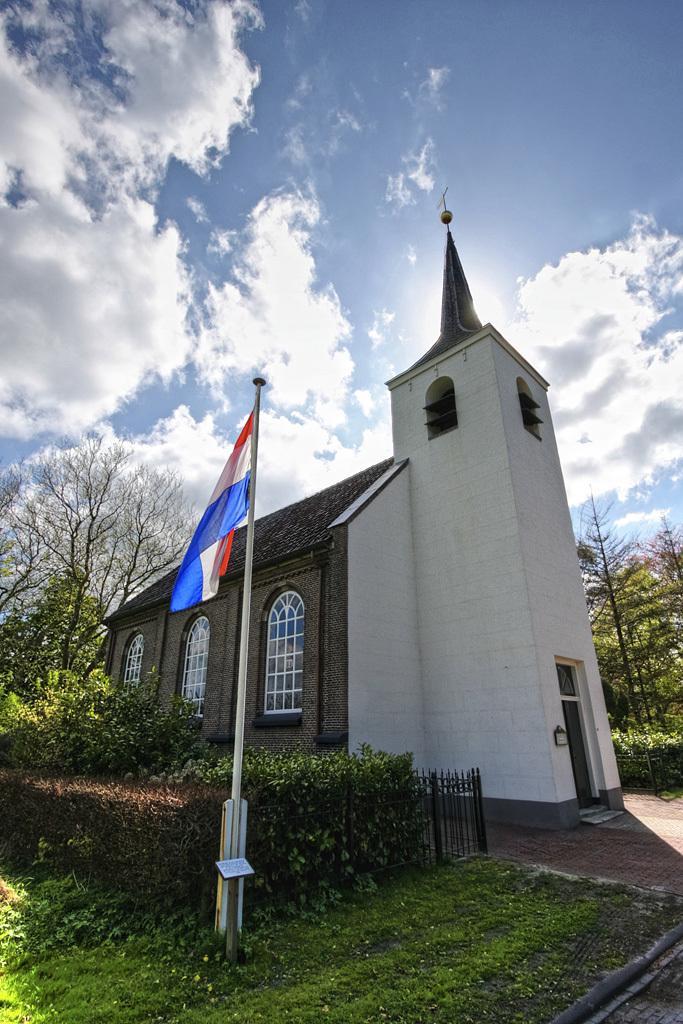How would you summarize this image in a sentence or two? In the center of the image we can see two poles, one flag, paper, etc. In the background, we can see the sky, clouds, one building, windows, grass, trees and fence. 